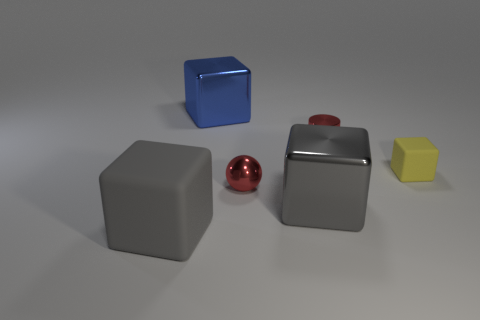Subtract all big blocks. How many blocks are left? 1 Subtract all cyan balls. How many gray cubes are left? 2 Add 1 large rubber cubes. How many objects exist? 7 Subtract all blue cubes. How many cubes are left? 3 Subtract all yellow blocks. Subtract all brown cylinders. How many blocks are left? 3 Subtract all spheres. How many objects are left? 5 Subtract all large blue rubber things. Subtract all big gray cubes. How many objects are left? 4 Add 3 gray rubber things. How many gray rubber things are left? 4 Add 6 tiny cyan shiny things. How many tiny cyan shiny things exist? 6 Subtract 0 purple blocks. How many objects are left? 6 